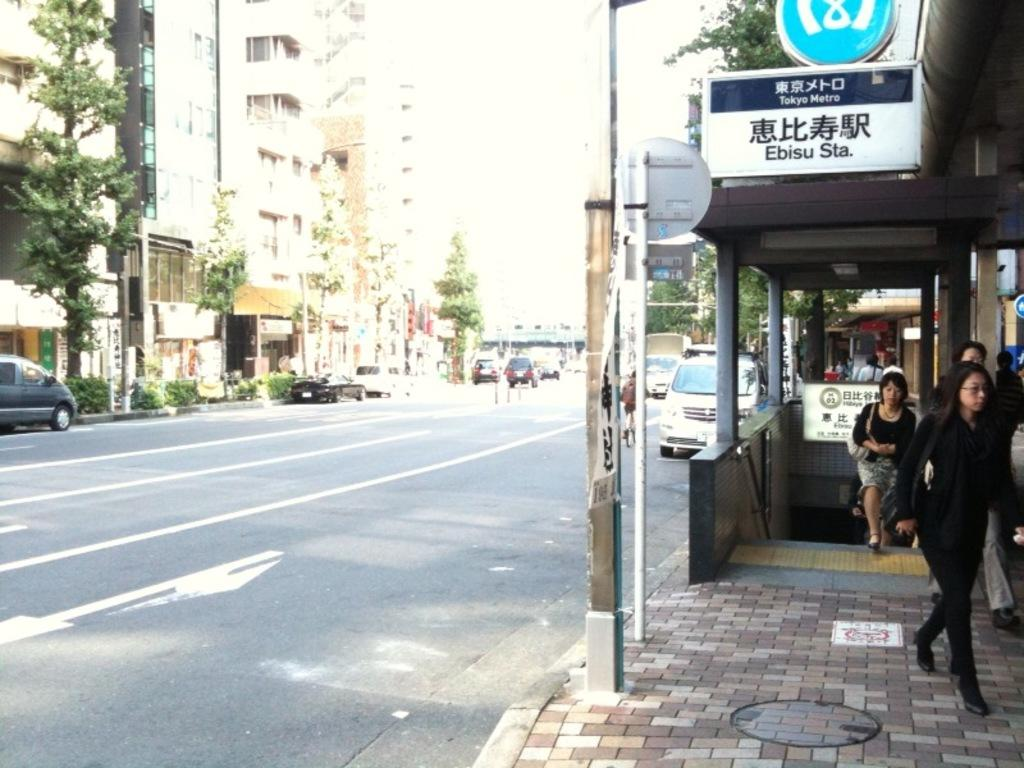<image>
Relay a brief, clear account of the picture shown. Some women are leaving from a Tokyo Metro station 